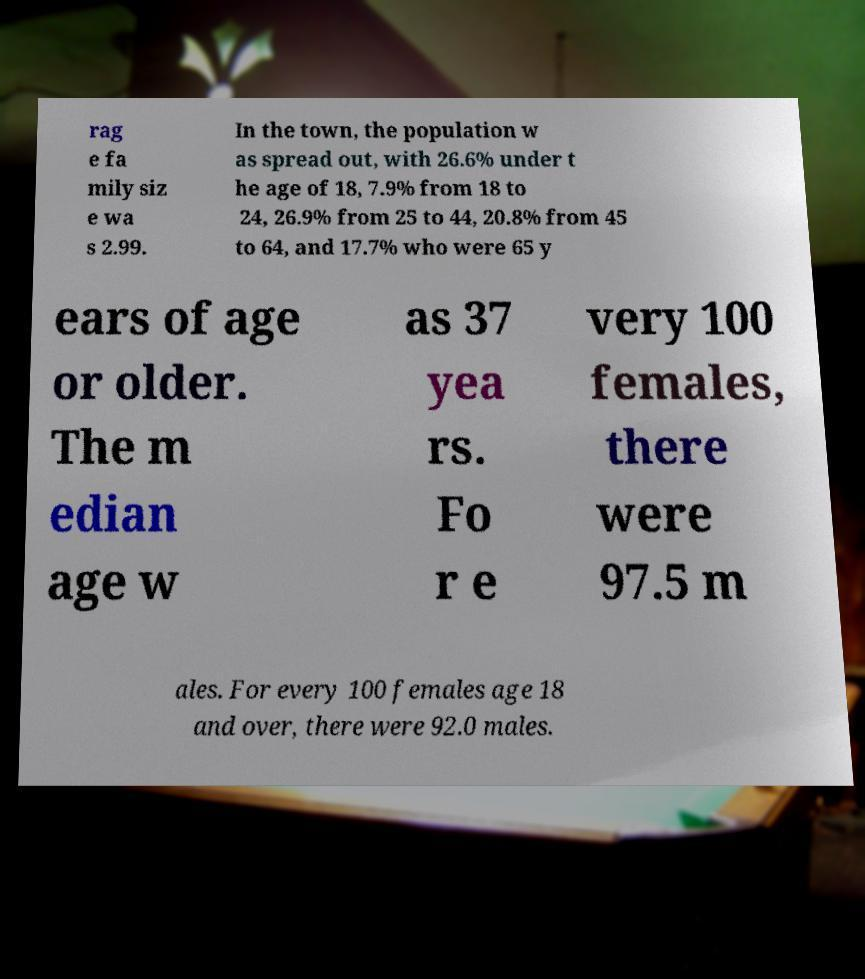There's text embedded in this image that I need extracted. Can you transcribe it verbatim? rag e fa mily siz e wa s 2.99. In the town, the population w as spread out, with 26.6% under t he age of 18, 7.9% from 18 to 24, 26.9% from 25 to 44, 20.8% from 45 to 64, and 17.7% who were 65 y ears of age or older. The m edian age w as 37 yea rs. Fo r e very 100 females, there were 97.5 m ales. For every 100 females age 18 and over, there were 92.0 males. 